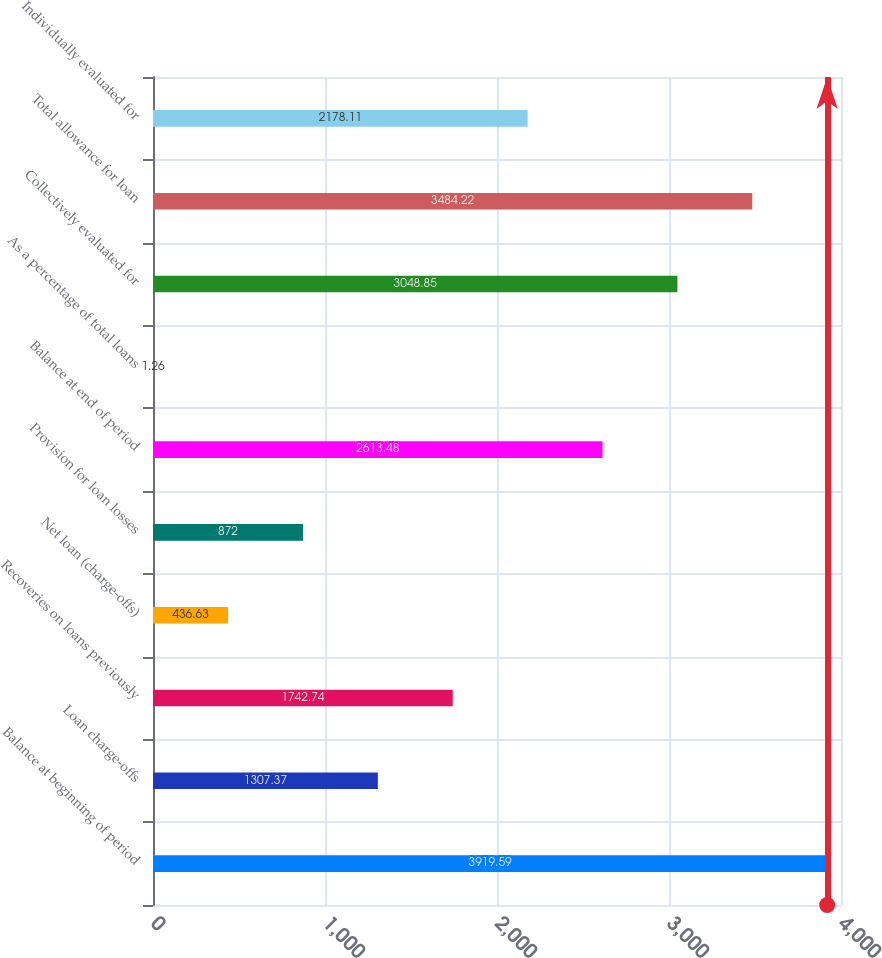<chart> <loc_0><loc_0><loc_500><loc_500><bar_chart><fcel>Balance at beginning of period<fcel>Loan charge-offs<fcel>Recoveries on loans previously<fcel>Net loan (charge-offs)<fcel>Provision for loan losses<fcel>Balance at end of period<fcel>As a percentage of total loans<fcel>Collectively evaluated for<fcel>Total allowance for loan<fcel>Individually evaluated for<nl><fcel>3919.59<fcel>1307.37<fcel>1742.74<fcel>436.63<fcel>872<fcel>2613.48<fcel>1.26<fcel>3048.85<fcel>3484.22<fcel>2178.11<nl></chart> 